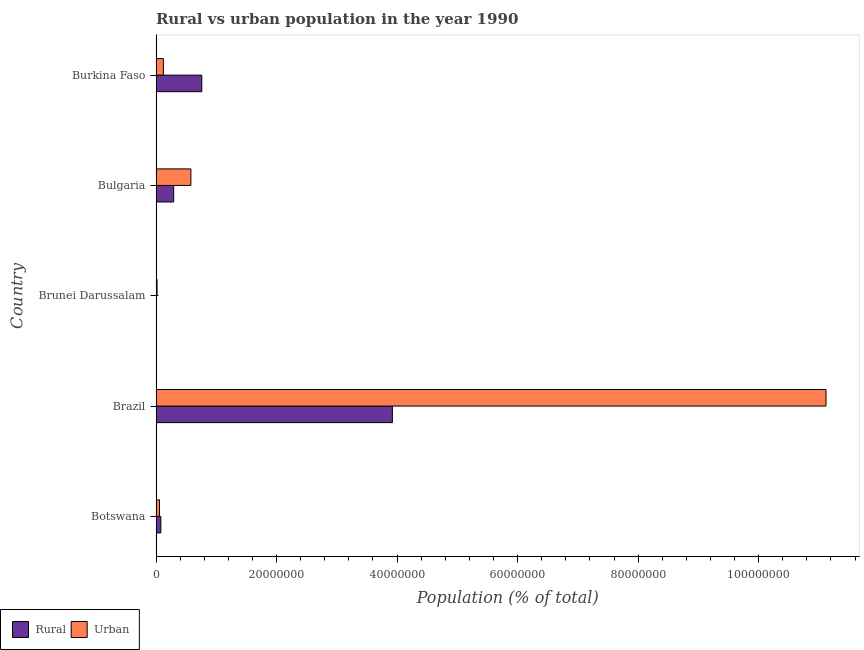How many bars are there on the 2nd tick from the top?
Your response must be concise. 2. How many bars are there on the 1st tick from the bottom?
Your answer should be compact. 2. What is the label of the 5th group of bars from the top?
Offer a very short reply. Botswana. In how many cases, is the number of bars for a given country not equal to the number of legend labels?
Give a very brief answer. 0. What is the urban population density in Brunei Darussalam?
Provide a succinct answer. 1.69e+05. Across all countries, what is the maximum rural population density?
Your answer should be very brief. 3.92e+07. Across all countries, what is the minimum urban population density?
Your answer should be very brief. 1.69e+05. In which country was the rural population density maximum?
Your answer should be very brief. Brazil. In which country was the rural population density minimum?
Your response must be concise. Brunei Darussalam. What is the total urban population density in the graph?
Keep it short and to the point. 1.19e+08. What is the difference between the urban population density in Botswana and that in Brazil?
Your answer should be compact. -1.11e+08. What is the difference between the rural population density in Bulgaria and the urban population density in Brazil?
Ensure brevity in your answer.  -1.08e+08. What is the average rural population density per country?
Your response must be concise. 1.01e+07. What is the difference between the urban population density and rural population density in Brunei Darussalam?
Your answer should be compact. 8.14e+04. In how many countries, is the urban population density greater than 68000000 %?
Your response must be concise. 1. What is the ratio of the urban population density in Botswana to that in Brazil?
Offer a terse response. 0.01. Is the urban population density in Brazil less than that in Burkina Faso?
Offer a very short reply. No. Is the difference between the urban population density in Brazil and Bulgaria greater than the difference between the rural population density in Brazil and Bulgaria?
Keep it short and to the point. Yes. What is the difference between the highest and the second highest urban population density?
Your answer should be very brief. 1.05e+08. What is the difference between the highest and the lowest urban population density?
Give a very brief answer. 1.11e+08. In how many countries, is the rural population density greater than the average rural population density taken over all countries?
Give a very brief answer. 1. What does the 1st bar from the top in Brazil represents?
Offer a terse response. Urban. What does the 2nd bar from the bottom in Botswana represents?
Your response must be concise. Urban. How many bars are there?
Provide a short and direct response. 10. Are all the bars in the graph horizontal?
Give a very brief answer. Yes. How many countries are there in the graph?
Provide a succinct answer. 5. What is the difference between two consecutive major ticks on the X-axis?
Offer a terse response. 2.00e+07. Does the graph contain any zero values?
Your response must be concise. No. How many legend labels are there?
Provide a succinct answer. 2. What is the title of the graph?
Provide a short and direct response. Rural vs urban population in the year 1990. What is the label or title of the X-axis?
Your answer should be compact. Population (% of total). What is the Population (% of total) of Rural in Botswana?
Offer a terse response. 8.01e+05. What is the Population (% of total) of Urban in Botswana?
Your answer should be compact. 5.79e+05. What is the Population (% of total) in Rural in Brazil?
Make the answer very short. 3.92e+07. What is the Population (% of total) of Urban in Brazil?
Give a very brief answer. 1.11e+08. What is the Population (% of total) in Rural in Brunei Darussalam?
Your answer should be compact. 8.78e+04. What is the Population (% of total) of Urban in Brunei Darussalam?
Keep it short and to the point. 1.69e+05. What is the Population (% of total) of Rural in Bulgaria?
Give a very brief answer. 2.93e+06. What is the Population (% of total) of Urban in Bulgaria?
Offer a terse response. 5.79e+06. What is the Population (% of total) in Rural in Burkina Faso?
Give a very brief answer. 7.59e+06. What is the Population (% of total) in Urban in Burkina Faso?
Your response must be concise. 1.22e+06. Across all countries, what is the maximum Population (% of total) in Rural?
Offer a terse response. 3.92e+07. Across all countries, what is the maximum Population (% of total) in Urban?
Offer a very short reply. 1.11e+08. Across all countries, what is the minimum Population (% of total) of Rural?
Ensure brevity in your answer.  8.78e+04. Across all countries, what is the minimum Population (% of total) of Urban?
Keep it short and to the point. 1.69e+05. What is the total Population (% of total) of Rural in the graph?
Your answer should be very brief. 5.06e+07. What is the total Population (% of total) of Urban in the graph?
Your answer should be very brief. 1.19e+08. What is the difference between the Population (% of total) of Rural in Botswana and that in Brazil?
Provide a succinct answer. -3.84e+07. What is the difference between the Population (% of total) in Urban in Botswana and that in Brazil?
Make the answer very short. -1.11e+08. What is the difference between the Population (% of total) of Rural in Botswana and that in Brunei Darussalam?
Your response must be concise. 7.13e+05. What is the difference between the Population (% of total) in Urban in Botswana and that in Brunei Darussalam?
Your answer should be very brief. 4.09e+05. What is the difference between the Population (% of total) of Rural in Botswana and that in Bulgaria?
Your answer should be compact. -2.13e+06. What is the difference between the Population (% of total) of Urban in Botswana and that in Bulgaria?
Give a very brief answer. -5.21e+06. What is the difference between the Population (% of total) in Rural in Botswana and that in Burkina Faso?
Your response must be concise. -6.79e+06. What is the difference between the Population (% of total) of Urban in Botswana and that in Burkina Faso?
Offer a very short reply. -6.39e+05. What is the difference between the Population (% of total) in Rural in Brazil and that in Brunei Darussalam?
Make the answer very short. 3.91e+07. What is the difference between the Population (% of total) of Urban in Brazil and that in Brunei Darussalam?
Make the answer very short. 1.11e+08. What is the difference between the Population (% of total) of Rural in Brazil and that in Bulgaria?
Keep it short and to the point. 3.63e+07. What is the difference between the Population (% of total) of Urban in Brazil and that in Bulgaria?
Give a very brief answer. 1.05e+08. What is the difference between the Population (% of total) of Rural in Brazil and that in Burkina Faso?
Make the answer very short. 3.16e+07. What is the difference between the Population (% of total) of Urban in Brazil and that in Burkina Faso?
Keep it short and to the point. 1.10e+08. What is the difference between the Population (% of total) in Rural in Brunei Darussalam and that in Bulgaria?
Offer a very short reply. -2.84e+06. What is the difference between the Population (% of total) in Urban in Brunei Darussalam and that in Bulgaria?
Your answer should be compact. -5.62e+06. What is the difference between the Population (% of total) in Rural in Brunei Darussalam and that in Burkina Faso?
Provide a succinct answer. -7.51e+06. What is the difference between the Population (% of total) of Urban in Brunei Darussalam and that in Burkina Faso?
Your answer should be very brief. -1.05e+06. What is the difference between the Population (% of total) of Rural in Bulgaria and that in Burkina Faso?
Keep it short and to the point. -4.66e+06. What is the difference between the Population (% of total) in Urban in Bulgaria and that in Burkina Faso?
Your answer should be very brief. 4.57e+06. What is the difference between the Population (% of total) of Rural in Botswana and the Population (% of total) of Urban in Brazil?
Keep it short and to the point. -1.10e+08. What is the difference between the Population (% of total) in Rural in Botswana and the Population (% of total) in Urban in Brunei Darussalam?
Provide a succinct answer. 6.32e+05. What is the difference between the Population (% of total) of Rural in Botswana and the Population (% of total) of Urban in Bulgaria?
Offer a terse response. -4.99e+06. What is the difference between the Population (% of total) of Rural in Botswana and the Population (% of total) of Urban in Burkina Faso?
Ensure brevity in your answer.  -4.16e+05. What is the difference between the Population (% of total) in Rural in Brazil and the Population (% of total) in Urban in Brunei Darussalam?
Keep it short and to the point. 3.91e+07. What is the difference between the Population (% of total) of Rural in Brazil and the Population (% of total) of Urban in Bulgaria?
Offer a very short reply. 3.34e+07. What is the difference between the Population (% of total) of Rural in Brazil and the Population (% of total) of Urban in Burkina Faso?
Provide a short and direct response. 3.80e+07. What is the difference between the Population (% of total) in Rural in Brunei Darussalam and the Population (% of total) in Urban in Bulgaria?
Ensure brevity in your answer.  -5.70e+06. What is the difference between the Population (% of total) of Rural in Brunei Darussalam and the Population (% of total) of Urban in Burkina Faso?
Ensure brevity in your answer.  -1.13e+06. What is the difference between the Population (% of total) of Rural in Bulgaria and the Population (% of total) of Urban in Burkina Faso?
Offer a very short reply. 1.71e+06. What is the average Population (% of total) of Rural per country?
Your answer should be very brief. 1.01e+07. What is the average Population (% of total) of Urban per country?
Give a very brief answer. 2.38e+07. What is the difference between the Population (% of total) of Rural and Population (% of total) of Urban in Botswana?
Provide a succinct answer. 2.23e+05. What is the difference between the Population (% of total) of Rural and Population (% of total) of Urban in Brazil?
Your answer should be compact. -7.20e+07. What is the difference between the Population (% of total) in Rural and Population (% of total) in Urban in Brunei Darussalam?
Your response must be concise. -8.14e+04. What is the difference between the Population (% of total) of Rural and Population (% of total) of Urban in Bulgaria?
Your answer should be very brief. -2.86e+06. What is the difference between the Population (% of total) in Rural and Population (% of total) in Urban in Burkina Faso?
Provide a short and direct response. 6.38e+06. What is the ratio of the Population (% of total) of Rural in Botswana to that in Brazil?
Give a very brief answer. 0.02. What is the ratio of the Population (% of total) in Urban in Botswana to that in Brazil?
Provide a short and direct response. 0.01. What is the ratio of the Population (% of total) in Rural in Botswana to that in Brunei Darussalam?
Your response must be concise. 9.13. What is the ratio of the Population (% of total) of Urban in Botswana to that in Brunei Darussalam?
Your answer should be compact. 3.42. What is the ratio of the Population (% of total) of Rural in Botswana to that in Bulgaria?
Your answer should be compact. 0.27. What is the ratio of the Population (% of total) in Urban in Botswana to that in Bulgaria?
Offer a terse response. 0.1. What is the ratio of the Population (% of total) in Rural in Botswana to that in Burkina Faso?
Your answer should be very brief. 0.11. What is the ratio of the Population (% of total) in Urban in Botswana to that in Burkina Faso?
Give a very brief answer. 0.48. What is the ratio of the Population (% of total) of Rural in Brazil to that in Brunei Darussalam?
Your answer should be very brief. 446.75. What is the ratio of the Population (% of total) in Urban in Brazil to that in Brunei Darussalam?
Keep it short and to the point. 657.24. What is the ratio of the Population (% of total) in Rural in Brazil to that in Bulgaria?
Your answer should be compact. 13.38. What is the ratio of the Population (% of total) in Urban in Brazil to that in Bulgaria?
Your response must be concise. 19.21. What is the ratio of the Population (% of total) of Rural in Brazil to that in Burkina Faso?
Your answer should be compact. 5.16. What is the ratio of the Population (% of total) of Urban in Brazil to that in Burkina Faso?
Your answer should be compact. 91.33. What is the ratio of the Population (% of total) of Rural in Brunei Darussalam to that in Bulgaria?
Provide a succinct answer. 0.03. What is the ratio of the Population (% of total) of Urban in Brunei Darussalam to that in Bulgaria?
Keep it short and to the point. 0.03. What is the ratio of the Population (% of total) of Rural in Brunei Darussalam to that in Burkina Faso?
Your response must be concise. 0.01. What is the ratio of the Population (% of total) of Urban in Brunei Darussalam to that in Burkina Faso?
Give a very brief answer. 0.14. What is the ratio of the Population (% of total) of Rural in Bulgaria to that in Burkina Faso?
Your answer should be very brief. 0.39. What is the ratio of the Population (% of total) in Urban in Bulgaria to that in Burkina Faso?
Keep it short and to the point. 4.75. What is the difference between the highest and the second highest Population (% of total) of Rural?
Provide a succinct answer. 3.16e+07. What is the difference between the highest and the second highest Population (% of total) in Urban?
Make the answer very short. 1.05e+08. What is the difference between the highest and the lowest Population (% of total) in Rural?
Keep it short and to the point. 3.91e+07. What is the difference between the highest and the lowest Population (% of total) of Urban?
Keep it short and to the point. 1.11e+08. 